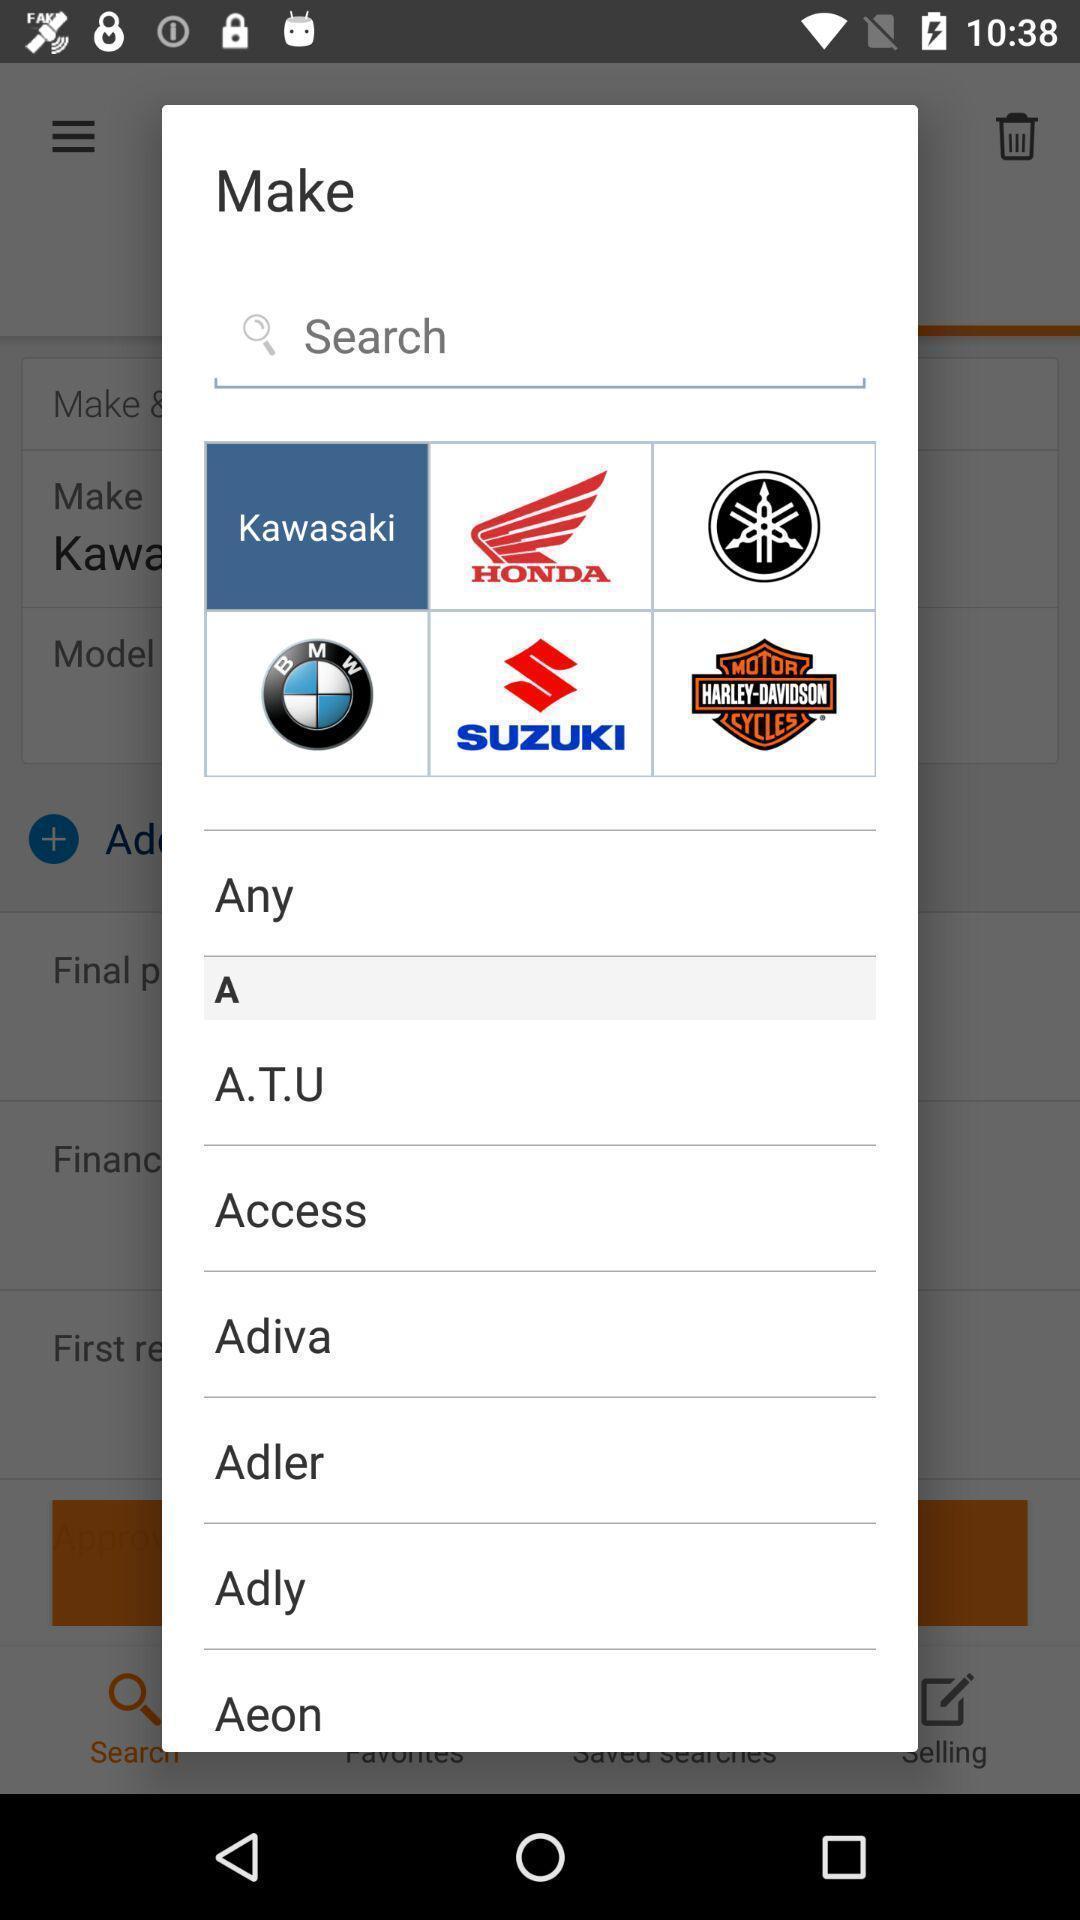Provide a detailed account of this screenshot. Search page to find different vehicles. 